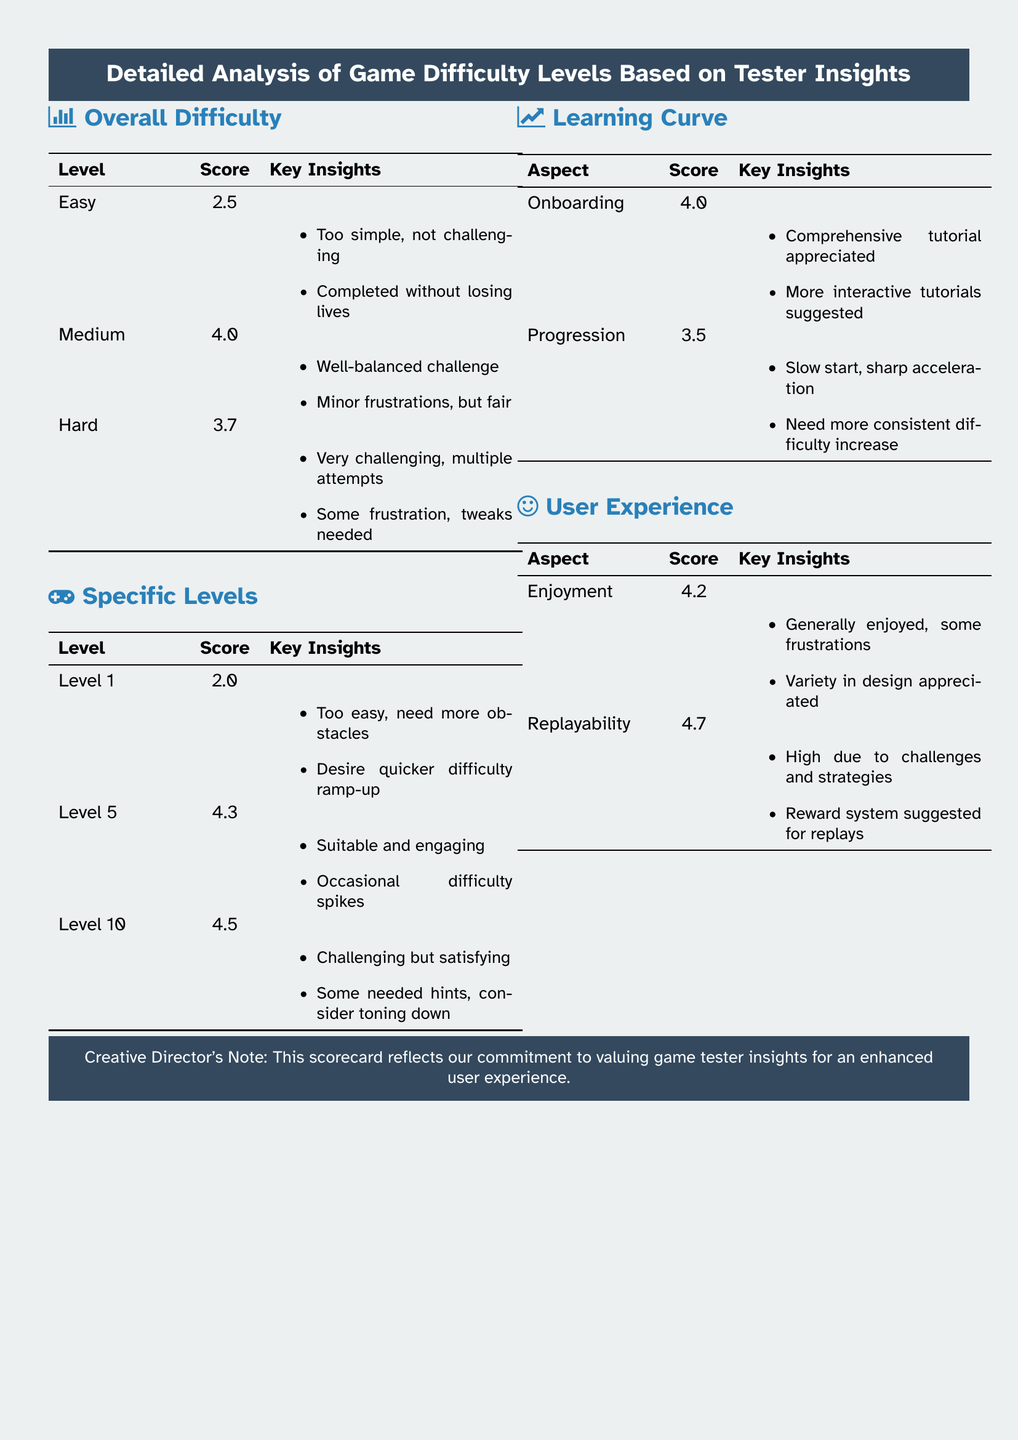What is the score for Easy difficulty? The score for Easy difficulty is listed in the Overall Difficulty section of the document, which is 2.5.
Answer: 2.5 What insights were provided for Level 10? The key insights for Level 10 can be found in the Specific Levels section, which are "Challenging but satisfying" and "Some needed hints, consider toning down."
Answer: Challenging but satisfying; Some needed hints, consider toning down What is the overall score for replayability? The overall score for replayability can be found in the User Experience section of the document, which is 4.7.
Answer: 4.7 What was suggested to improve onboarding? The document mentions in the Learning Curve section that more interactive tutorials are suggested to improve onboarding.
Answer: More interactive tutorials What were testers' feelings towards Medium difficulty? The key insights provided in the Overall Difficulty section indicate that testers felt it was a "Well-balanced challenge" with "Minor frustrations, but fair."
Answer: Well-balanced challenge; Minor frustrations, but fair How did testers feel about Level 5? The insights for Level 5, found in the Specific Levels section, are "Suitable and engaging" and "Occasional difficulty spikes."
Answer: Suitable and engaging; Occasional difficulty spikes What is the score for Hard difficulty? The score for Hard difficulty is stated in the Overall Difficulty section of the document, which is 3.7.
Answer: 3.7 What aspect received the highest score in User Experience? The aspect with the highest score in the User Experience section is Replayability, which received a score of 4.7.
Answer: Replayability What general note does the Creative Director provide? The Creative Director's note at the bottom of the document states the scorecard reflects a commitment to valuing game tester insights for an enhanced user experience.
Answer: Valuing game tester insights for an enhanced user experience 